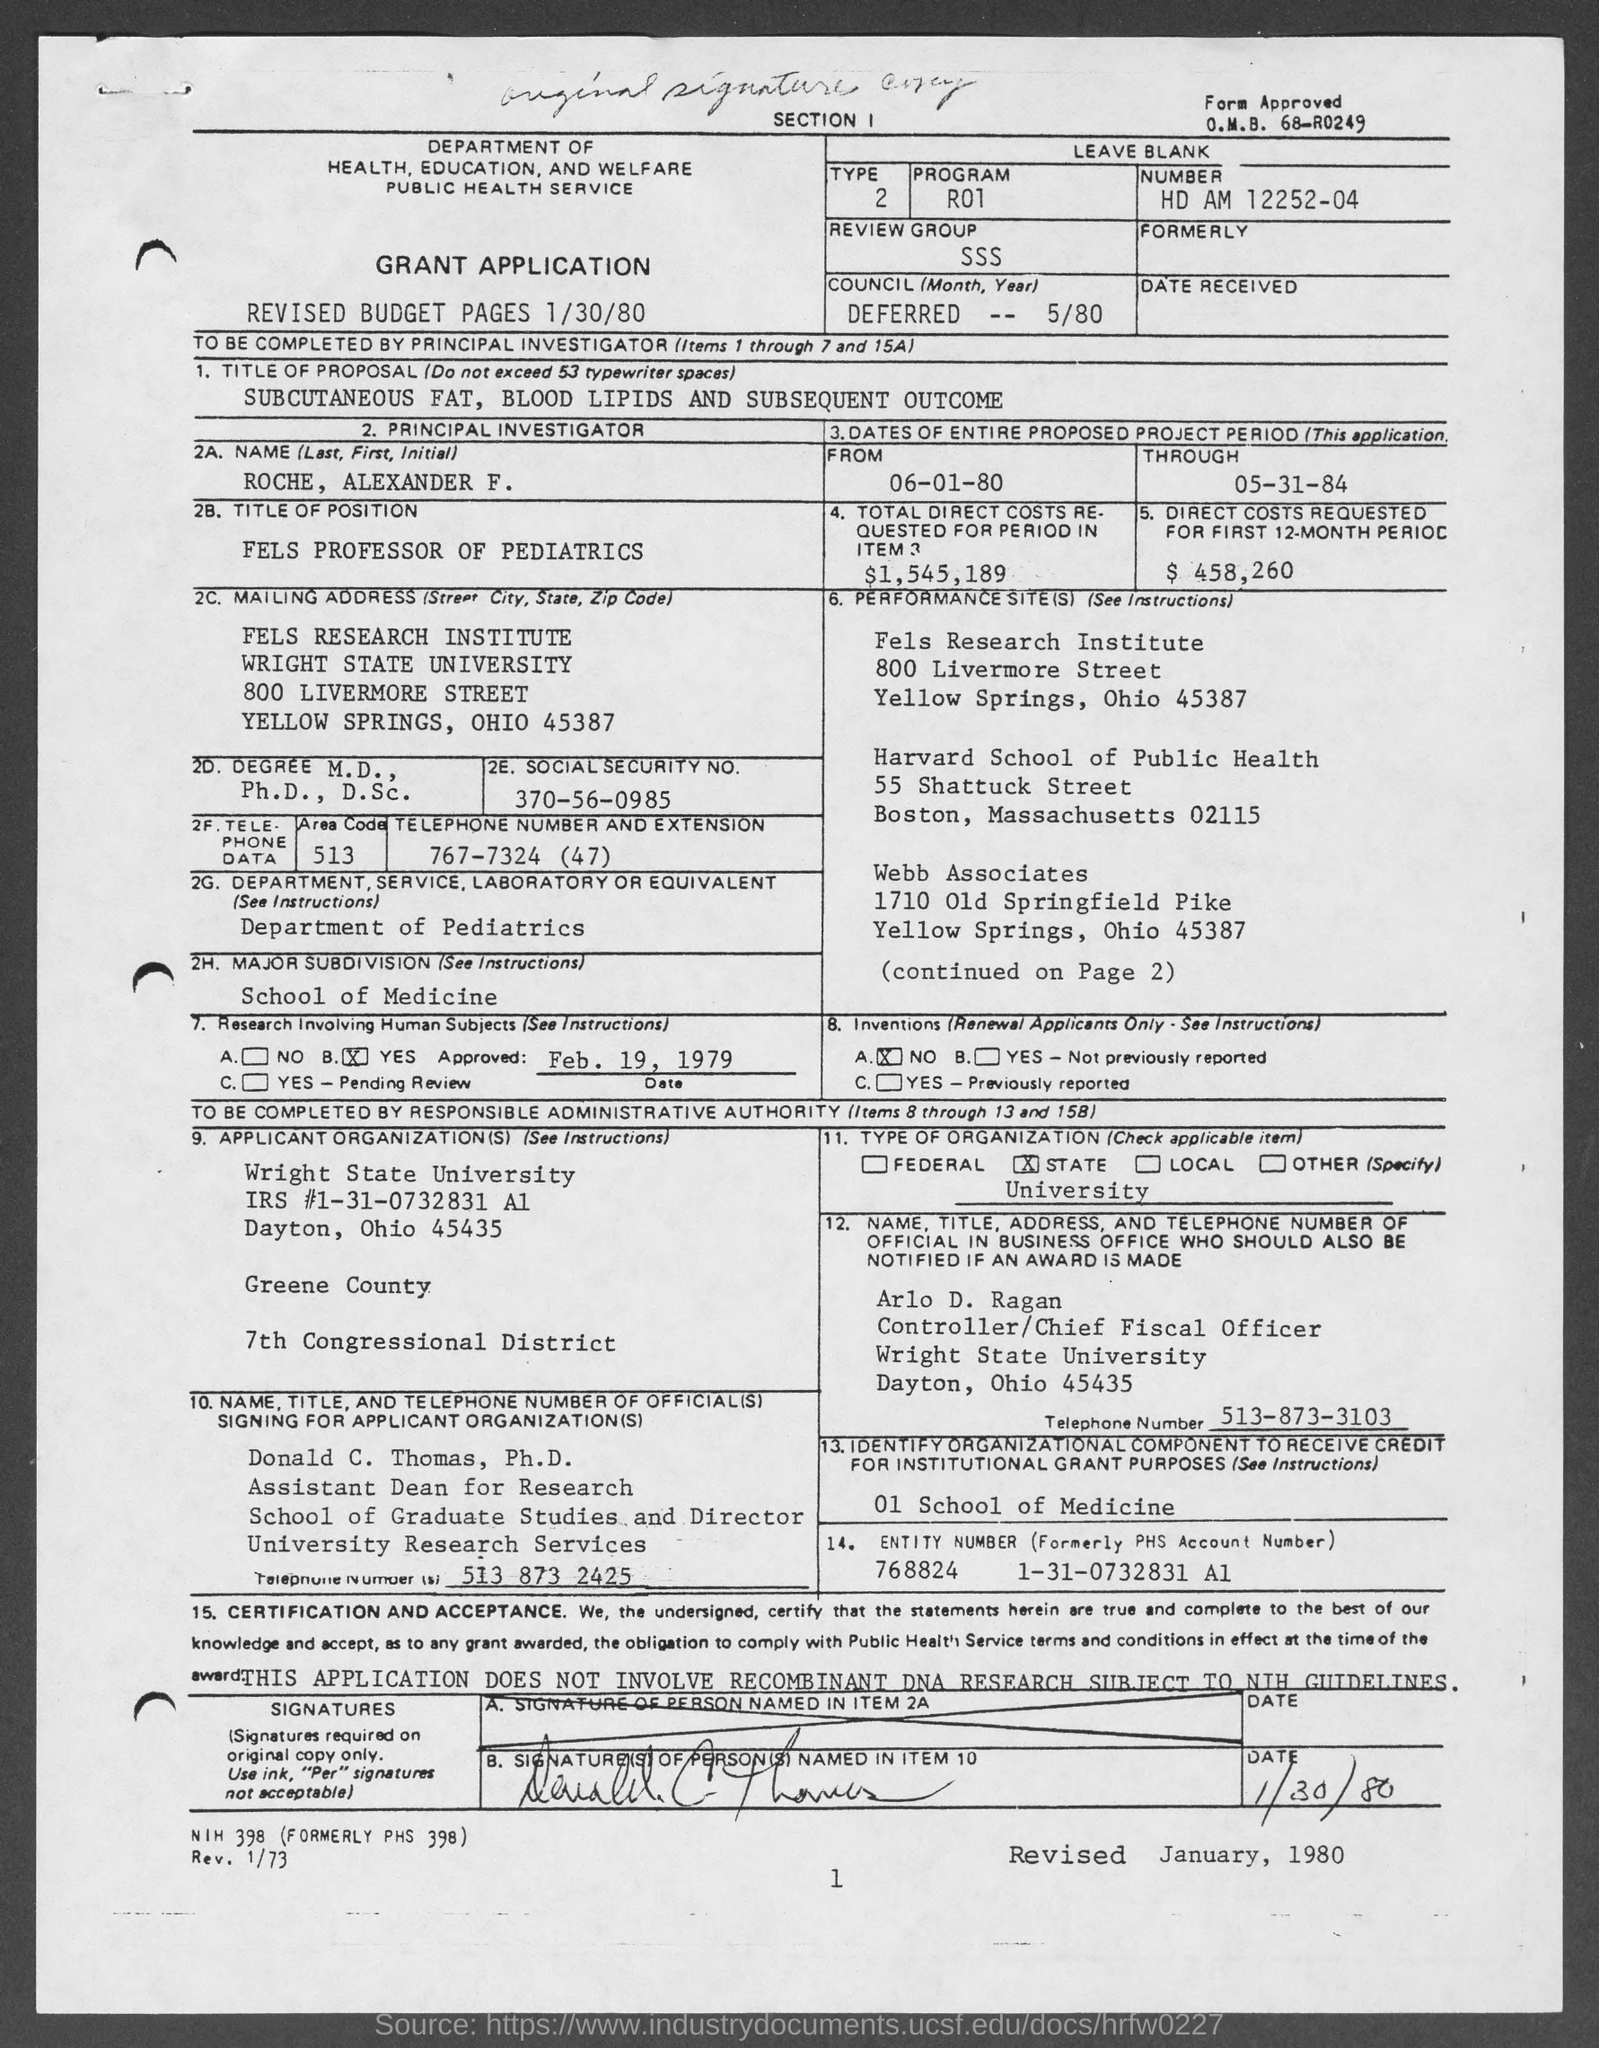What is the name mentioned ?( last , first , initial )
Make the answer very short. Roche, Alexander F. What is the approved date in research involving human subjects
Your response must be concise. Feb. 19 , 1979. What is the telephone number of arlo d. ragan
Keep it short and to the point. 513-873-3103. What is the entity number (formerly phs account number )
Your answer should be very brief. 768824 1-31-0732831 A1. What is the date mentioned ?
Make the answer very short. 1/30/80. What is the revised date mentioned ?
Offer a very short reply. January , 1980. What is the program no ?
Provide a short and direct response. R01. 